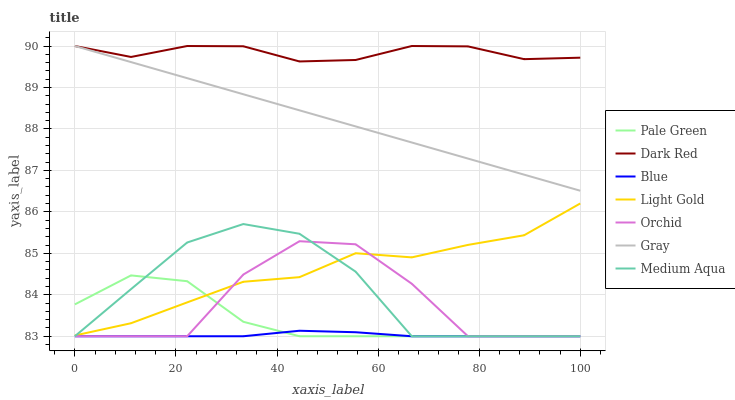Does Blue have the minimum area under the curve?
Answer yes or no. Yes. Does Dark Red have the maximum area under the curve?
Answer yes or no. Yes. Does Gray have the minimum area under the curve?
Answer yes or no. No. Does Gray have the maximum area under the curve?
Answer yes or no. No. Is Gray the smoothest?
Answer yes or no. Yes. Is Orchid the roughest?
Answer yes or no. Yes. Is Dark Red the smoothest?
Answer yes or no. No. Is Dark Red the roughest?
Answer yes or no. No. Does Blue have the lowest value?
Answer yes or no. Yes. Does Gray have the lowest value?
Answer yes or no. No. Does Dark Red have the highest value?
Answer yes or no. Yes. Does Pale Green have the highest value?
Answer yes or no. No. Is Blue less than Light Gold?
Answer yes or no. Yes. Is Dark Red greater than Medium Aqua?
Answer yes or no. Yes. Does Medium Aqua intersect Light Gold?
Answer yes or no. Yes. Is Medium Aqua less than Light Gold?
Answer yes or no. No. Is Medium Aqua greater than Light Gold?
Answer yes or no. No. Does Blue intersect Light Gold?
Answer yes or no. No. 